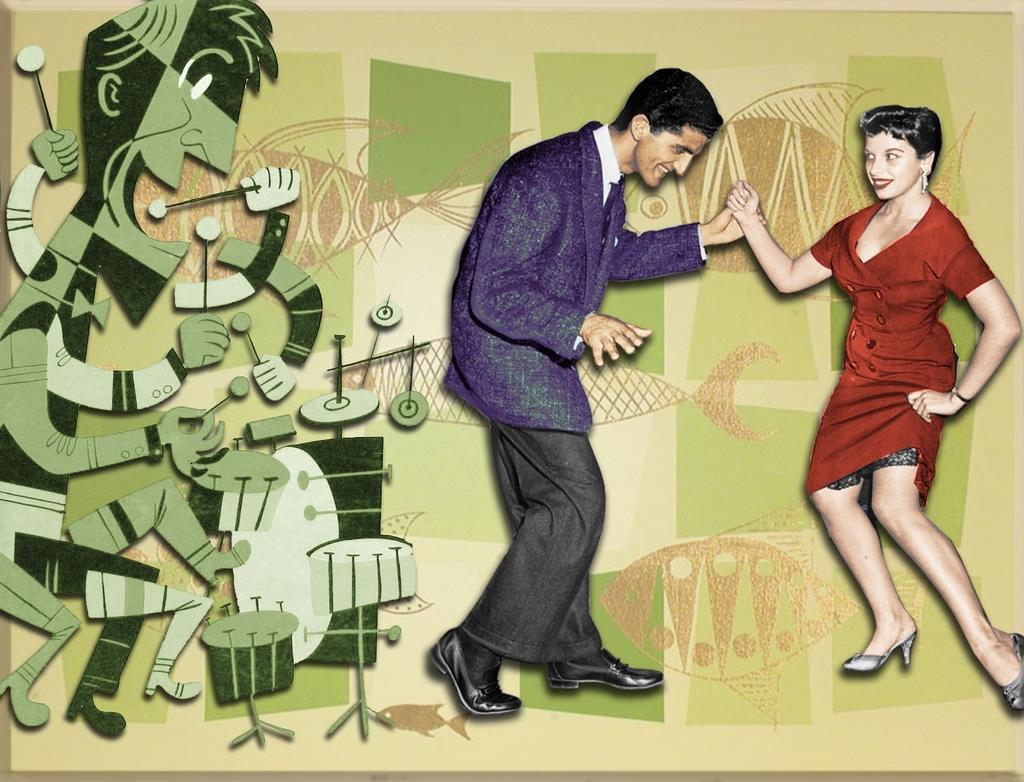Could you give a brief overview of what you see in this image? In this image we can see two persons and one big wall painted with pictures. 